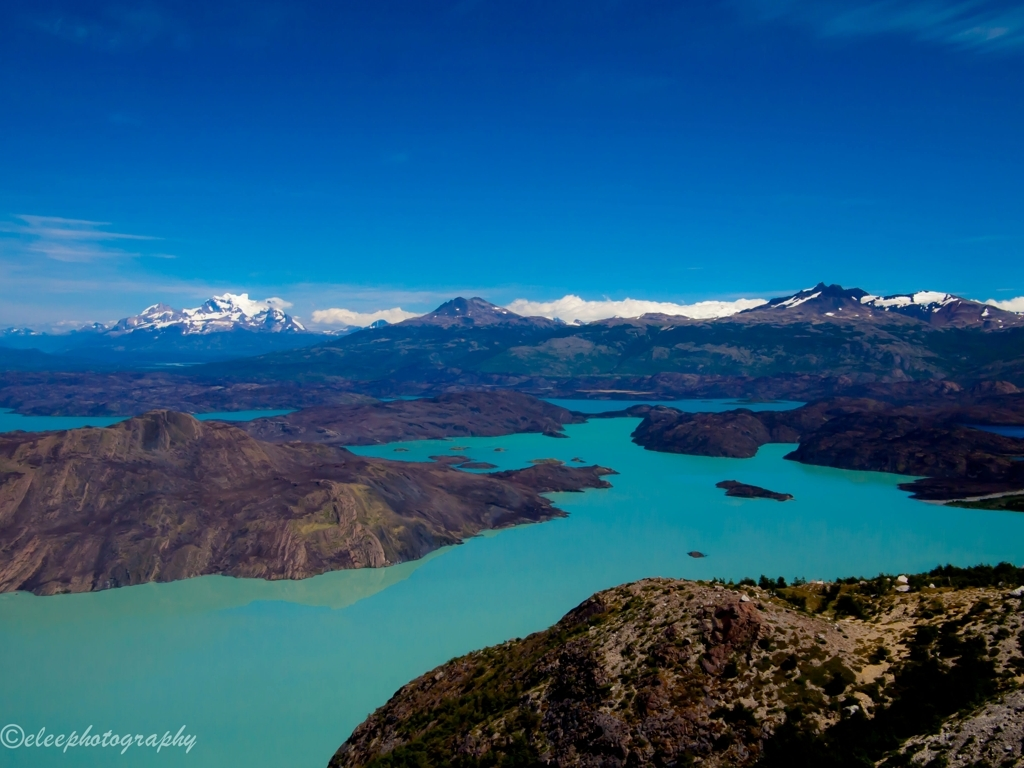Can you describe the geographical features visible in this image? This image showcases a diverse range of geographical features. In the foreground, we have rugged rocky terrain sloping towards a strikingly turquoise lake. The middle ground is dominated by rolling hills that fade into the lake, creating numerous inlets and peninsulas. In the distance, majestic snow-capped mountains rise against the blue sky, suggesting they might be part of a larger mountain range. 